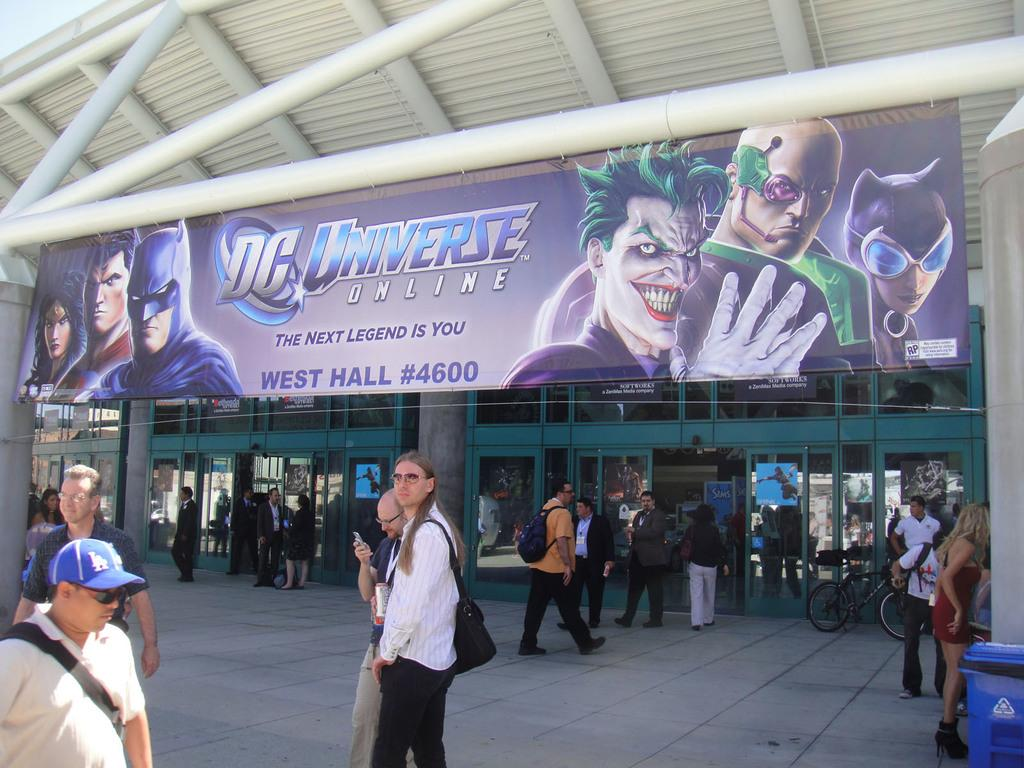<image>
Create a compact narrative representing the image presented. Big banner for dc universe online the next legend is you 